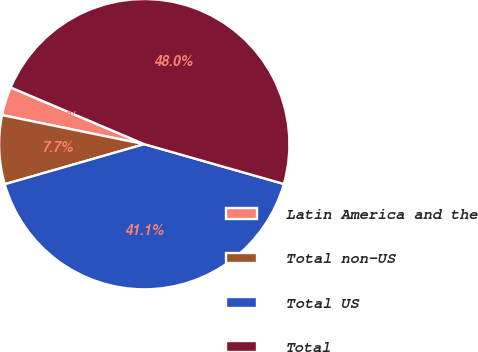Convert chart to OTSL. <chart><loc_0><loc_0><loc_500><loc_500><pie_chart><fcel>Latin America and the<fcel>Total non-US<fcel>Total US<fcel>Total<nl><fcel>3.18%<fcel>7.66%<fcel>41.13%<fcel>48.03%<nl></chart> 